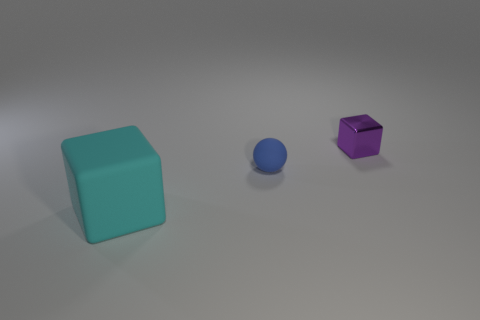Subtract all cyan blocks. How many blocks are left? 1 Add 1 large matte blocks. How many objects exist? 4 Subtract all blocks. How many objects are left? 1 Subtract 2 blocks. How many blocks are left? 0 Subtract all red cubes. Subtract all cyan balls. How many cubes are left? 2 Subtract all large blocks. Subtract all yellow matte cubes. How many objects are left? 2 Add 2 purple metal things. How many purple metal things are left? 3 Add 3 small purple blocks. How many small purple blocks exist? 4 Subtract 0 green cubes. How many objects are left? 3 